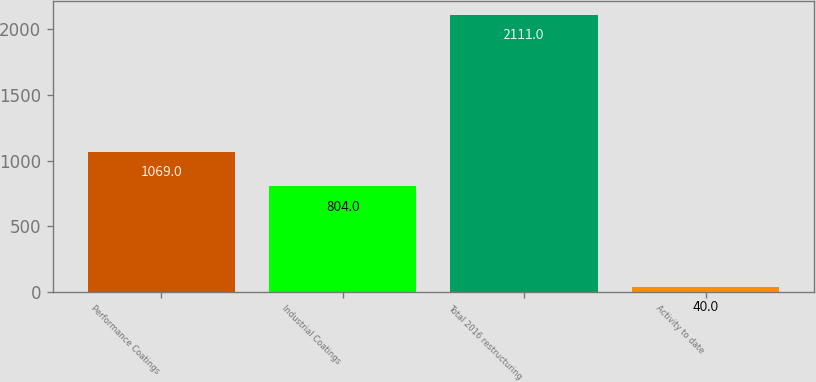Convert chart. <chart><loc_0><loc_0><loc_500><loc_500><bar_chart><fcel>Performance Coatings<fcel>Industrial Coatings<fcel>Total 2016 restructuring<fcel>Activity to date<nl><fcel>1069<fcel>804<fcel>2111<fcel>40<nl></chart> 